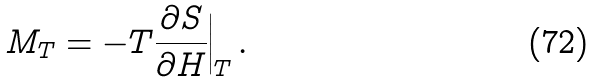<formula> <loc_0><loc_0><loc_500><loc_500>M _ { T } = - T \frac { \partial S } { \partial H } \Big | _ { T } \, .</formula> 